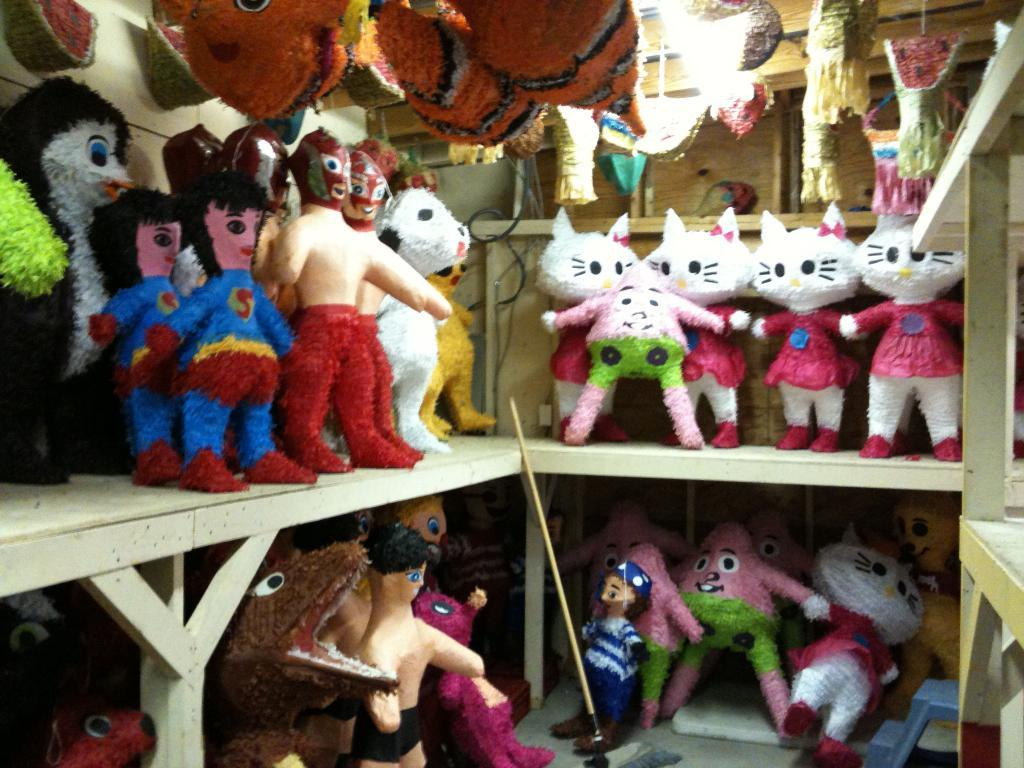What is placed in the racks in the image? There are toys placed in racks in the image. What can be seen in the background of the image? There is a wall in the background of the image. What type of baseball expansion can be seen in the image? There is no baseball or expansion present in the image; it features toys placed in racks and a wall in the background. 